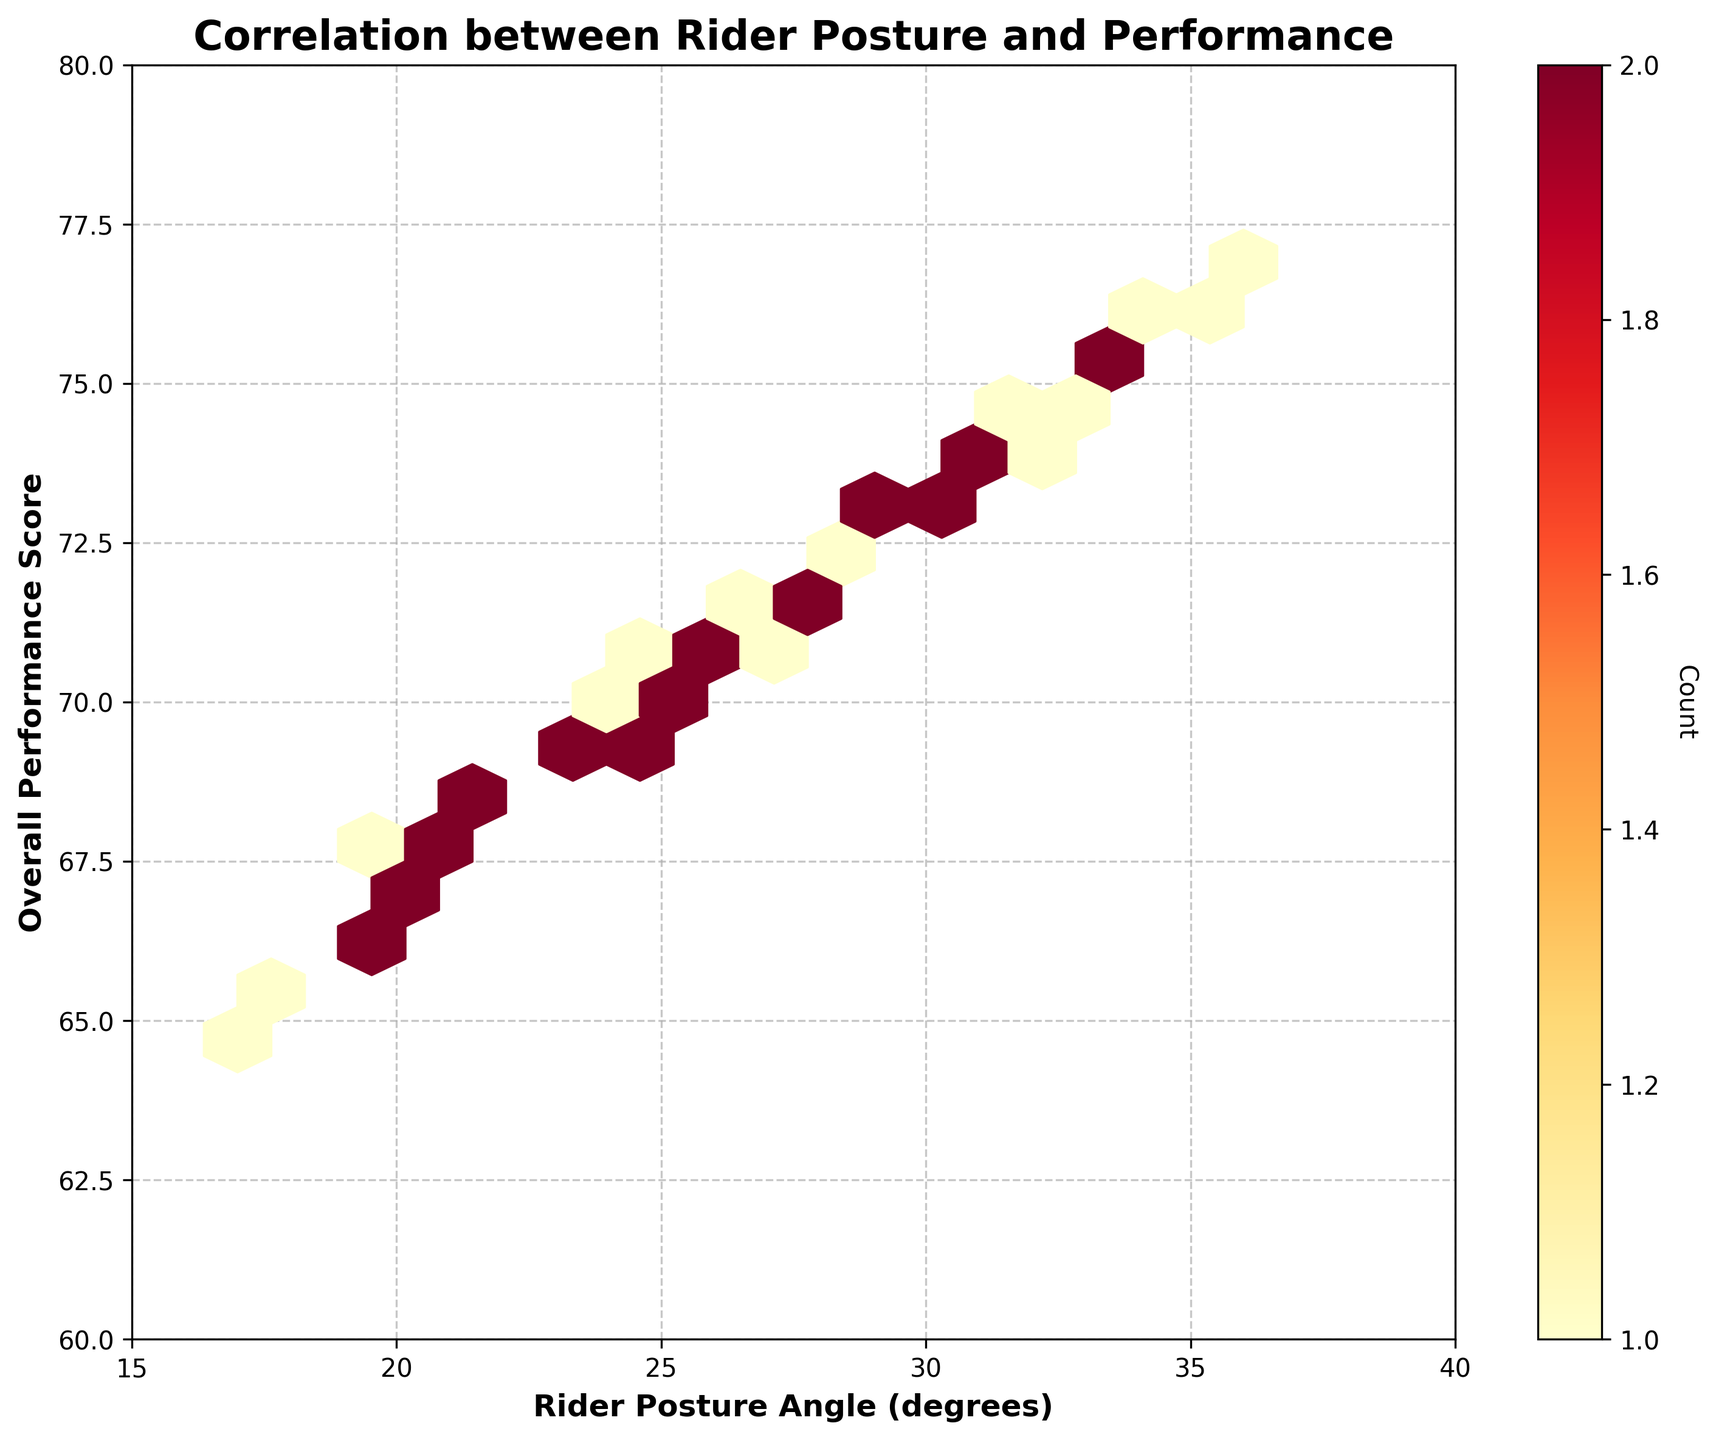What's the title of the hexbin plot? The title of a figure is usually placed at the top of the plot. In this case, it clearly states "Correlation between Rider Posture and Performance."
Answer: Correlation between Rider Posture and Performance What are the units for the x-axis label? The x-axis label is "Rider Posture Angle," followed by "(degrees)" which indicates the units.
Answer: degrees How many hexagons are shown in the plot? We can count the number of hexagons visible in the figure. Based on the gridsize parameter in the code, we expect around 15 x 15 hexagons, though not all may be visible due to data concentration.
Answer: Approximately 225 What's the range of Rider Posture Angle covered in this plot? The x-axis covers Rider Posture Angles from the minimum tick mark at around 15 degrees to the maximum tick mark at around 40 degrees.
Answer: 15 to 40 degrees Which color indicates the highest concentration of data points on the plot? The color bar on the right of the plot provides a reference for color intensity and count. The darkest red or maroon color typically indicates the highest concentration of data.
Answer: Darkest red/maroon What's the correlation trend between Rider Posture Angle and Overall Performance Score? By observing the alignment of the denser hexagons from the lower left to the upper right of the plot, we can deduce a positive correlation, meaning as the Rider Posture Angle increases, the Overall Performance Score also tends to increase.
Answer: Positive correlation What's the range of performance scores for the highest Rider Posture Angle group (between 35-36 degrees)? To determine this, identify the rightmost hexagons on the plot which cover about 35-36 degrees on the x-axis. Then, see the corresponding y-values they span, which are around 75 to 77.
Answer: 75 to 77 Are there more data points with Rider Posture Angles between 25-30 degrees or between 30-35 degrees? By comparing the density of hexagons in these two ranges on the x-axis, it can be observed that there are more and darker hexagons in the 25-30 degree range, indicating a higher concentration of data points.
Answer: 25-30 degrees How does the median performance score change with increasing Rider Posture Angles in the figure? Examine the trend in the y-axis values: lower posture angles (15-20 degrees) correspond with scores around 65-68, mid-ranges (25-30 degrees) with 70-73, and higher angles (35-40 degrees) with 75-77. This progressive increase implies that the median performance score increases as Rider Posture Angles increase.
Answer: It increases What is the lowest overall performance score observed in the figure, and at what Rider Posture Angle does it occur? The lowest score is the smallest value on the y-axis, appearing at around 64.7, with the corresponding Rider Posture Angle around 17 degrees.
Answer: 64.7 at 17 degrees 